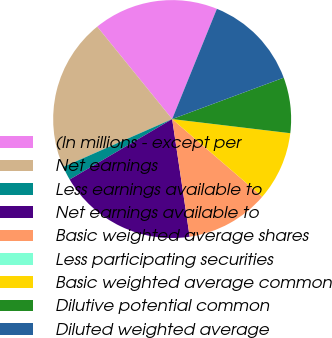Convert chart. <chart><loc_0><loc_0><loc_500><loc_500><pie_chart><fcel>(In millions - except per<fcel>Net earnings<fcel>Less earnings available to<fcel>Net earnings available to<fcel>Basic weighted average shares<fcel>Less participating securities<fcel>Basic weighted average common<fcel>Dilutive potential common<fcel>Diluted weighted average<nl><fcel>16.98%<fcel>20.75%<fcel>1.89%<fcel>18.87%<fcel>11.32%<fcel>0.0%<fcel>9.43%<fcel>7.55%<fcel>13.21%<nl></chart> 